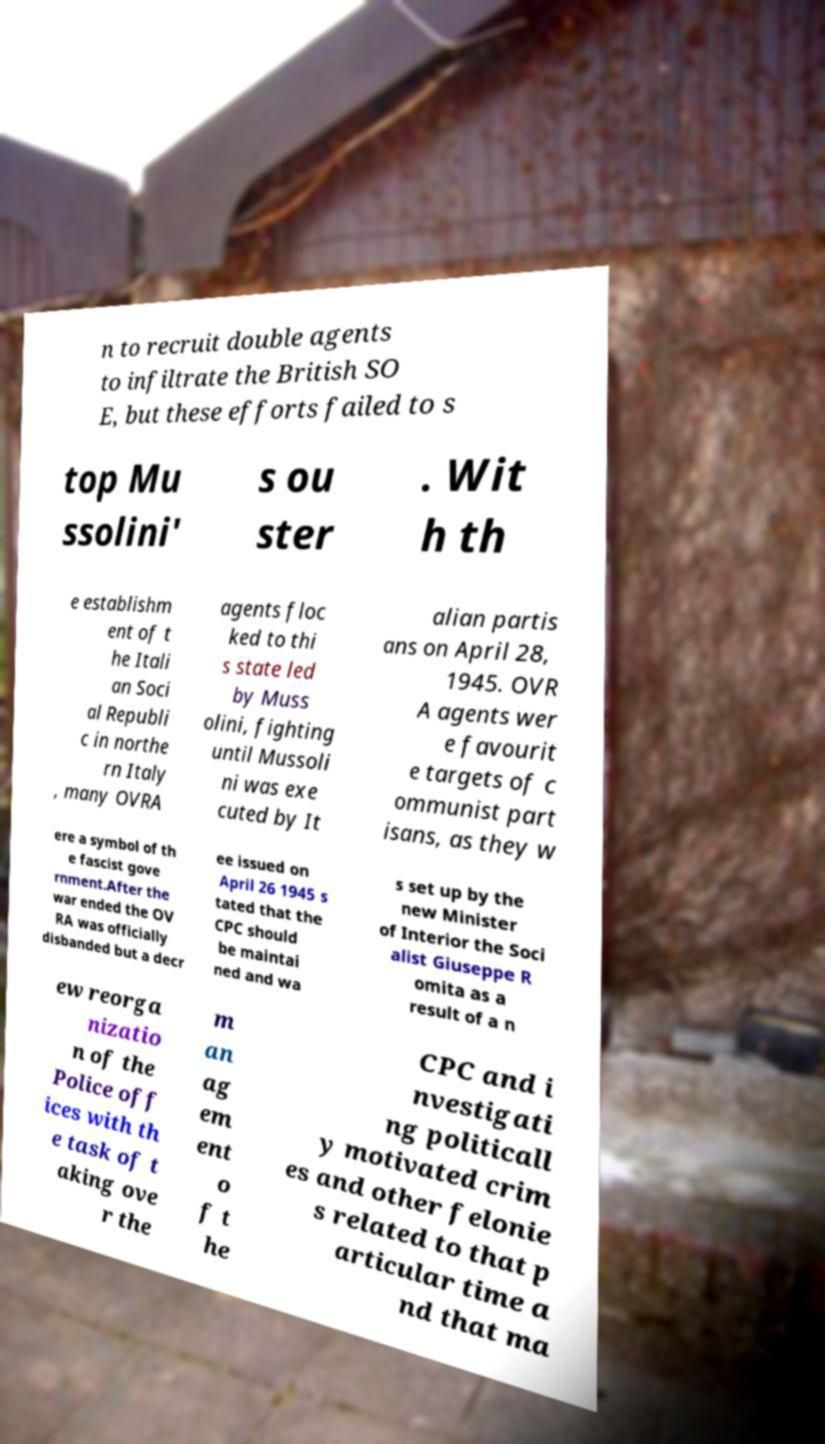For documentation purposes, I need the text within this image transcribed. Could you provide that? n to recruit double agents to infiltrate the British SO E, but these efforts failed to s top Mu ssolini' s ou ster . Wit h th e establishm ent of t he Itali an Soci al Republi c in northe rn Italy , many OVRA agents floc ked to thi s state led by Muss olini, fighting until Mussoli ni was exe cuted by It alian partis ans on April 28, 1945. OVR A agents wer e favourit e targets of c ommunist part isans, as they w ere a symbol of th e fascist gove rnment.After the war ended the OV RA was officially disbanded but a decr ee issued on April 26 1945 s tated that the CPC should be maintai ned and wa s set up by the new Minister of Interior the Soci alist Giuseppe R omita as a result of a n ew reorga nizatio n of the Police off ices with th e task of t aking ove r the m an ag em ent o f t he CPC and i nvestigati ng politicall y motivated crim es and other felonie s related to that p articular time a nd that ma 